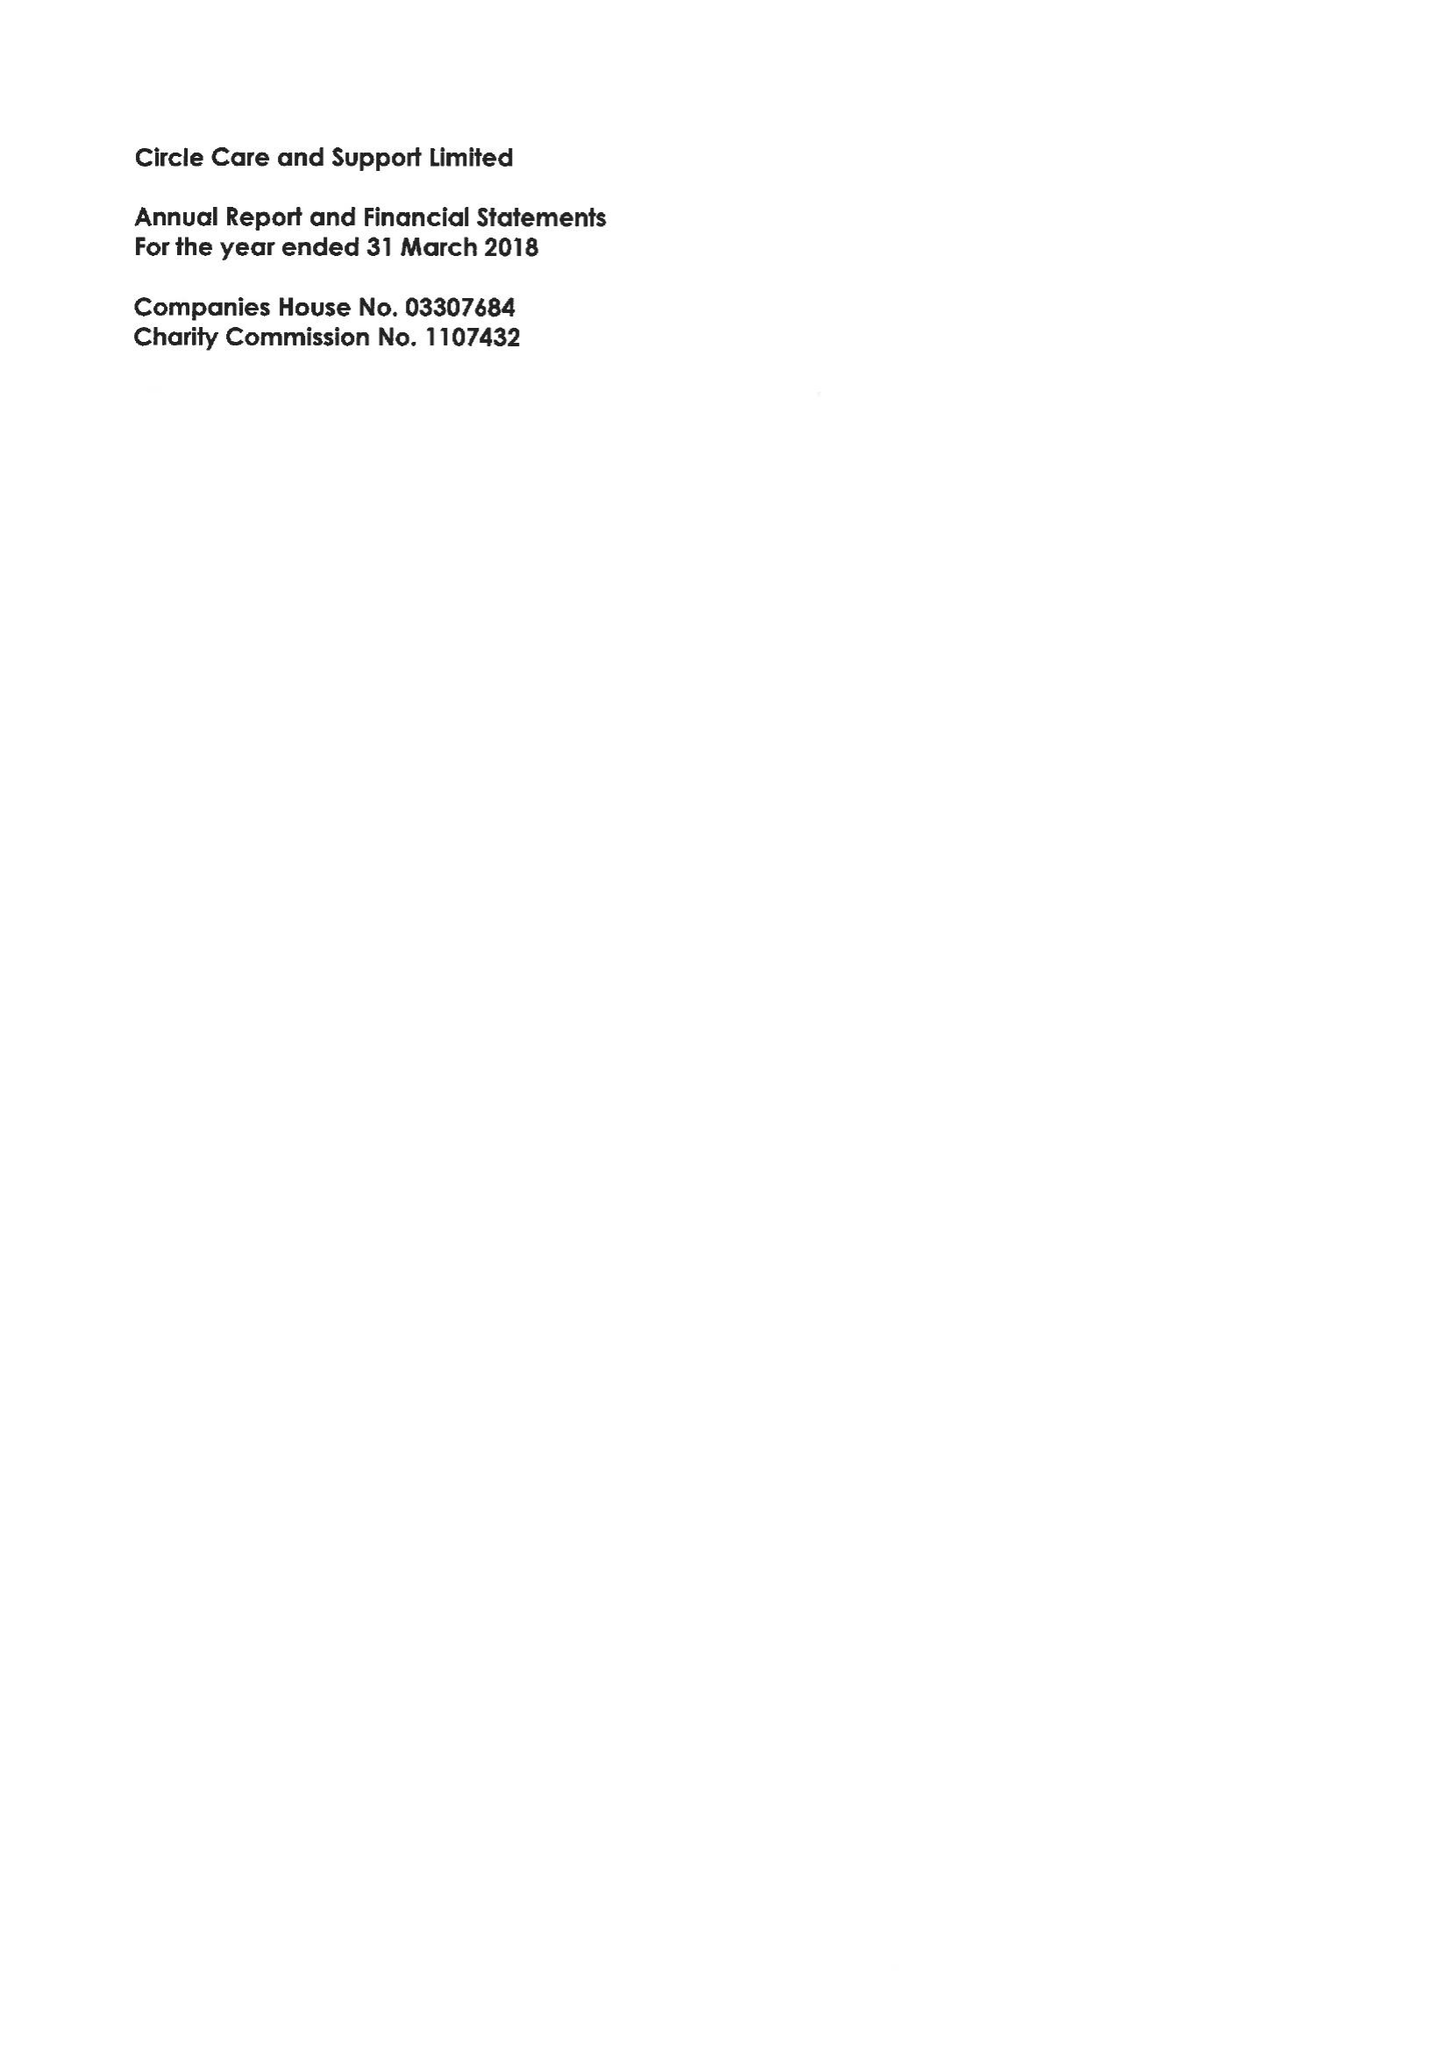What is the value for the income_annually_in_british_pounds?
Answer the question using a single word or phrase. 15521000.00 